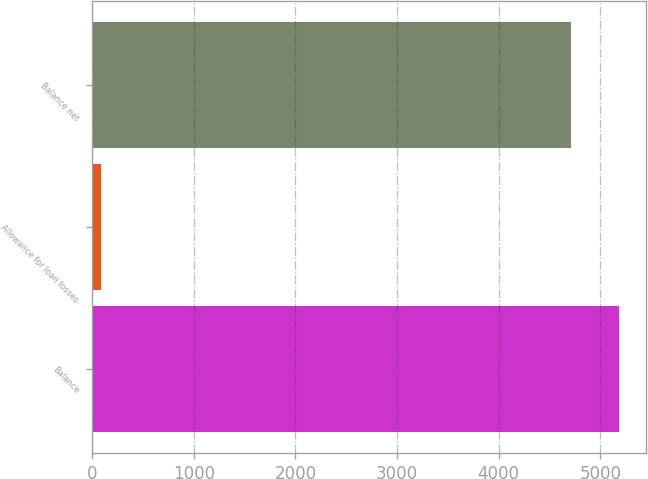Convert chart to OTSL. <chart><loc_0><loc_0><loc_500><loc_500><bar_chart><fcel>Balance<fcel>Allowance for loan losses<fcel>Balance net<nl><fcel>5186.5<fcel>89<fcel>4715<nl></chart> 